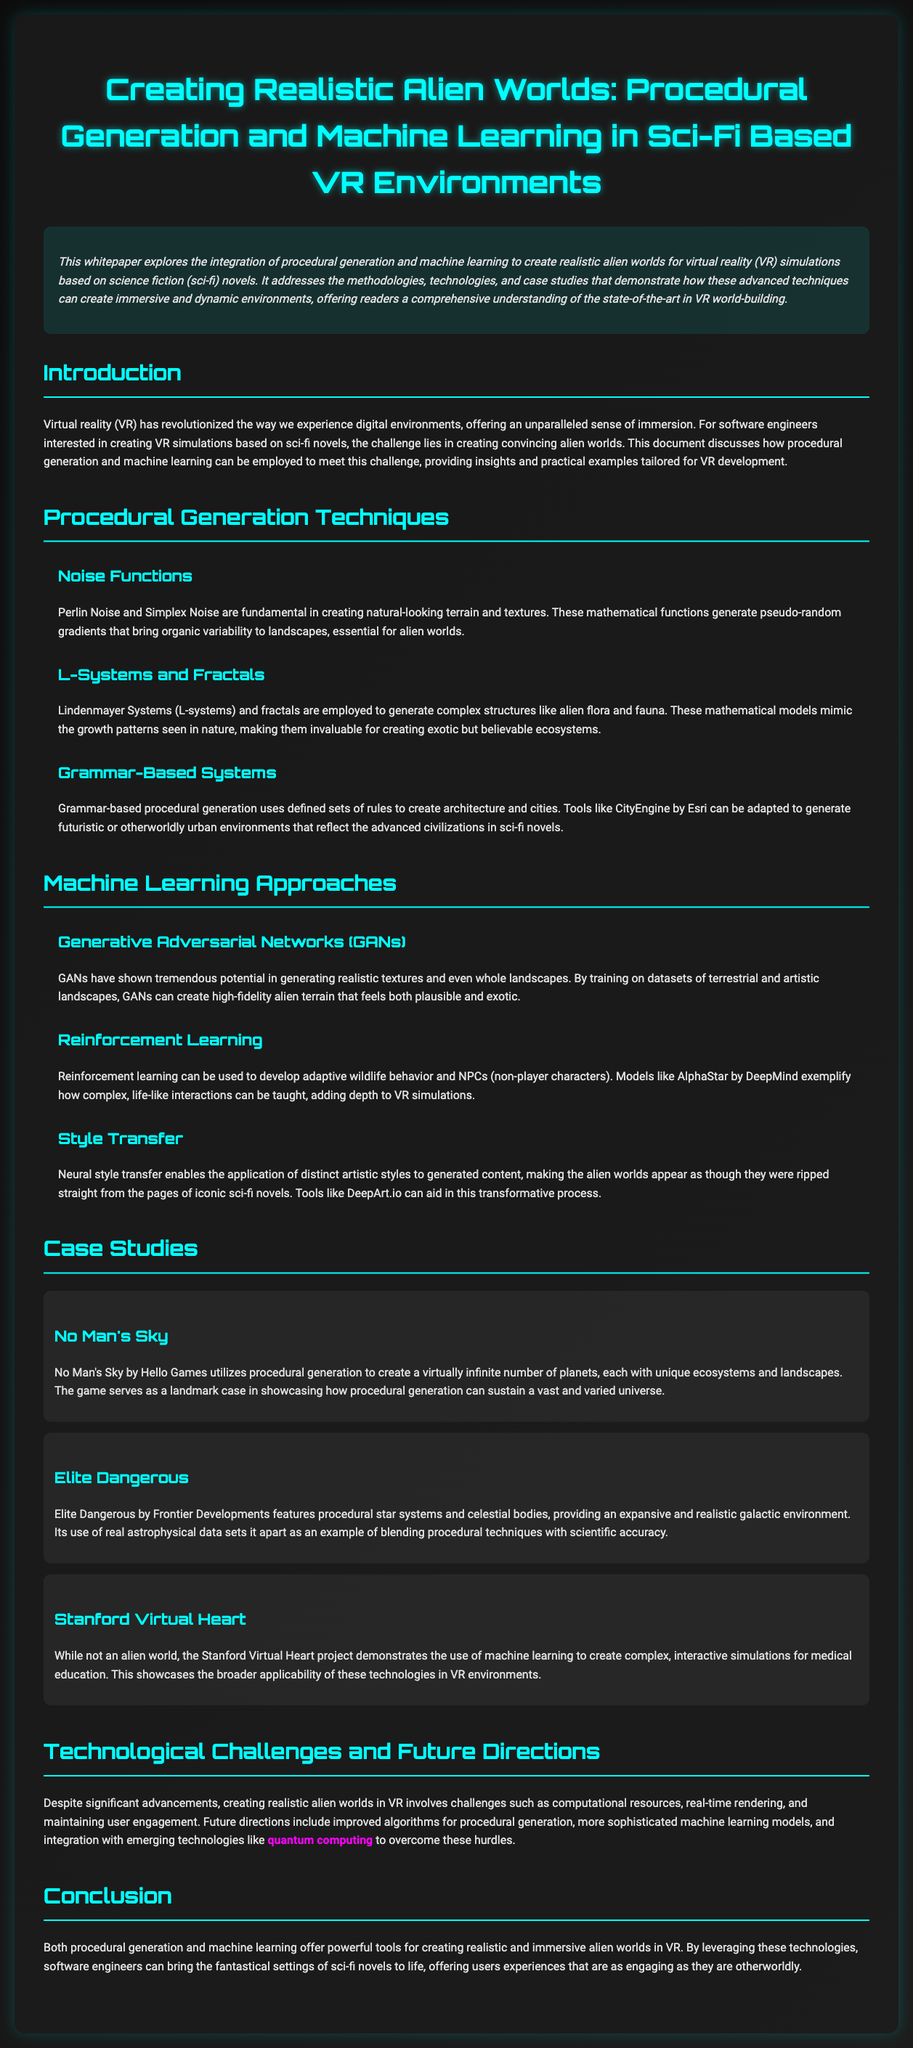What are the two main techniques discussed? The document primarily discusses procedural generation and machine learning as the two main techniques for creating alien worlds.
Answer: procedural generation and machine learning What is a key advantage of virtual reality according to the document? The document states that VR offers an unparalleled sense of immersion, which is a key advantage.
Answer: immersion What is one procedural generation technique mentioned? The document lists various techniques, and one example is Perlin Noise.
Answer: Perlin Noise Which machine learning model exemplifies adaptive wildlife behavior? The document mentions AlphaStar by DeepMind as an example of a model that showcases complexity in NPC interactions.
Answer: AlphaStar What game is highlighted for its use of procedural generation to create planets? The document references No Man's Sky as a landmark case for its use of procedural generation in creating unique ecosystems.
Answer: No Man's Sky What is one challenge mentioned in creating realistic alien worlds in VR? The document cites computational resources as a challenge faced in creating these environments.
Answer: computational resources What approach does neural style transfer relate to in the document? The document states that neural style transfer allows the application of distinct artistic styles to generated content.
Answer: artistic styles How do L-systems contribute to alien world creation? The document explains that L-systems and fractals are used to generate complex structures like alien flora and fauna.
Answer: complex structures What does the case study of the Stanford Virtual Heart project demonstrate? The document indicates that the project showcases the applicability of machine learning in interactive simulations for medical education.
Answer: interactive simulations 